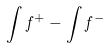<formula> <loc_0><loc_0><loc_500><loc_500>\int f ^ { + } - \int f ^ { - }</formula> 